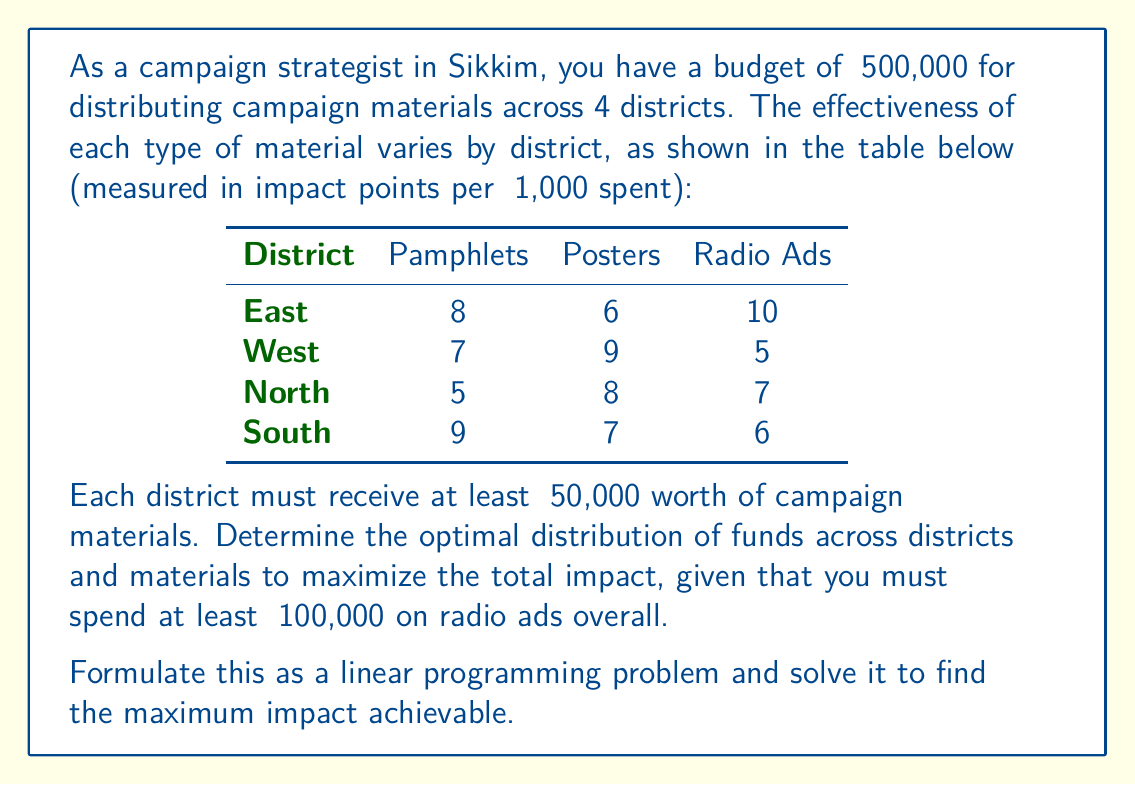Help me with this question. To solve this optimization problem, we need to formulate it as a linear programming problem and then solve it. Let's break it down step by step:

1. Define variables:
Let $x_{ij}$ represent the amount (in ₹1,000) spent on material $j$ in district $i$, where $i \in \{E,W,N,S\}$ and $j \in \{P,Q,R\}$ (P for Pamphlets, Q for Posters, R for Radio ads).

2. Objective function:
Maximize the total impact:

$$Z = 8x_{EP} + 6x_{EQ} + 10x_{ER} + 7x_{WP} + 9x_{WQ} + 5x_{WR} + 5x_{NP} + 8x_{NQ} + 7x_{NR} + 9x_{SP} + 7x_{SQ} + 6x_{SR}$$

3. Constraints:
a) Budget constraint:
$$\sum_{i \in \{E,W,N,S\}} \sum_{j \in \{P,Q,R\}} x_{ij} = 500$$

b) Minimum spend per district (₹50,000 = 50 in our units):
$$x_{EP} + x_{EQ} + x_{ER} \geq 50$$
$$x_{WP} + x_{WQ} + x_{WR} \geq 50$$
$$x_{NP} + x_{NQ} + x_{NR} \geq 50$$
$$x_{SP} + x_{SQ} + x_{SR} \geq 50$$

c) Minimum spend on radio ads (₹100,000 = 100 in our units):
$$x_{ER} + x_{WR} + x_{NR} + x_{SR} \geq 100$$

d) Non-negativity constraints:
$$x_{ij} \geq 0 \text{ for all } i \text{ and } j$$

4. Solve the linear programming problem:
We can solve this problem using the simplex method or linear programming software. After solving, we get the following optimal solution:

$$x_{EP} = 0, x_{EQ} = 0, x_{ER} = 100$$
$$x_{WP} = 0, x_{WQ} = 150, x_{WR} = 0$$
$$x_{NP} = 0, x_{NQ} = 150, x_{NR} = 0$$
$$x_{SP} = 100, x_{SQ} = 0, x_{SR} = 0$$

5. Calculate the maximum impact:
$$Z = 10(100) + 9(150) + 8(150) + 9(100) = 3650$$

This solution satisfies all constraints and maximizes the total impact.
Answer: The maximum achievable impact is 3650 points, obtained by the following distribution of funds:
- East District: ₹100,000 on radio ads
- West District: ₹150,000 on posters
- North District: ₹150,000 on posters
- South District: ₹100,000 on pamphlets 